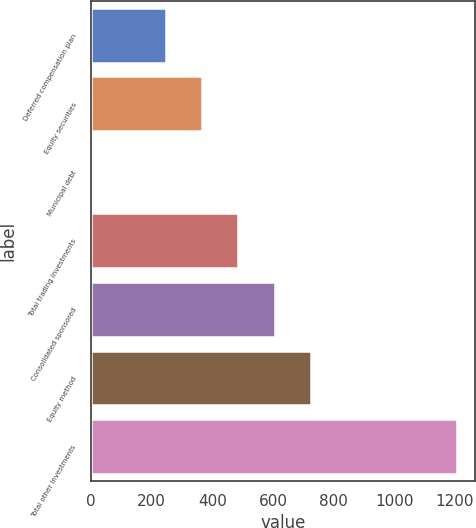Convert chart. <chart><loc_0><loc_0><loc_500><loc_500><bar_chart><fcel>Deferred compensation plan<fcel>Equity securities<fcel>Municipal debt<fcel>Total trading investments<fcel>Consolidated sponsored<fcel>Equity method<fcel>Total other investments<nl><fcel>246.8<fcel>366.7<fcel>7<fcel>486.6<fcel>606.5<fcel>726.4<fcel>1206<nl></chart> 